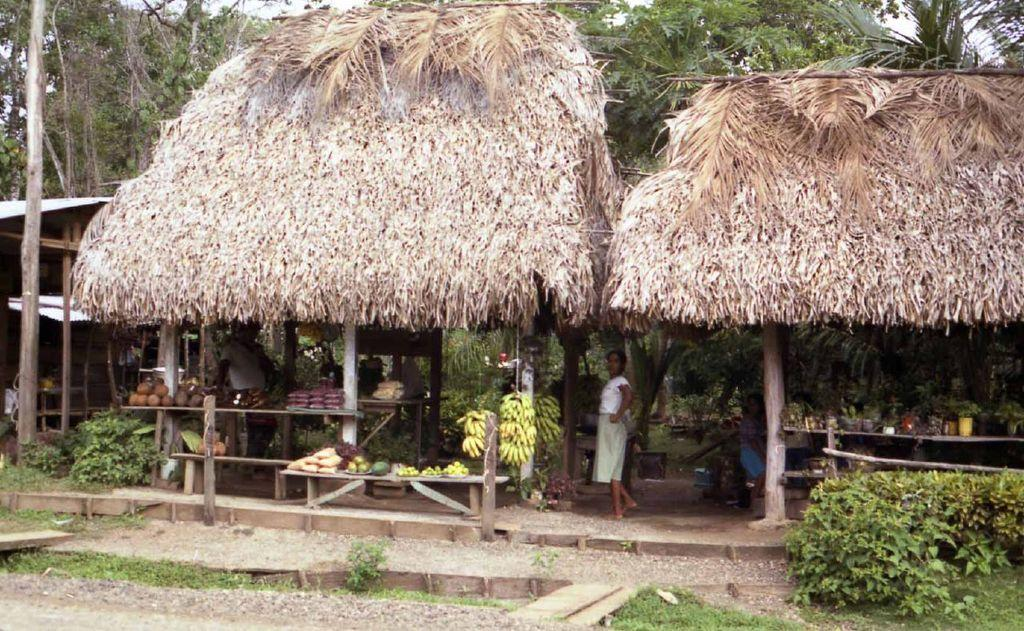What can be seen in the image that resembles a vertical structure? There are poles in the image. What type of plants are visible in the image? There are trees, vegetables, and fruits in the image. What are the flower pots placed on in the image? The flower pots are placed on wooden benches in the image. Is there any human presence in the image? Yes, one person is standing in front in the image. Can you see a tiger playing with a mitten in the waves in the image? There is no tiger, mitten, or waves present in the image. 